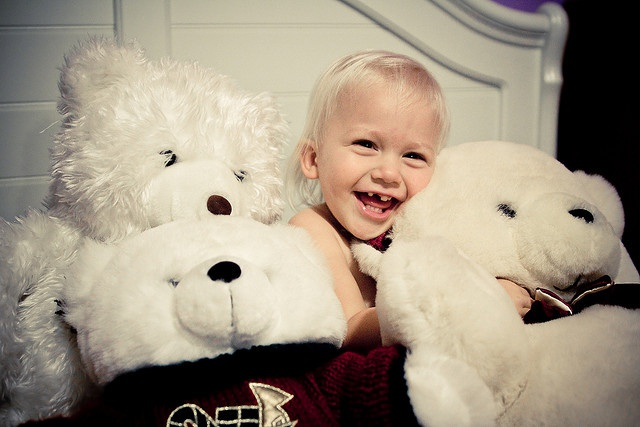Describe the objects in this image and their specific colors. I can see teddy bear in black, beige, and darkgray tones, teddy bear in black, tan, and gray tones, teddy bear in black, beige, tan, darkgray, and gray tones, bed in black, darkgray, beige, gray, and tan tones, and people in black and tan tones in this image. 